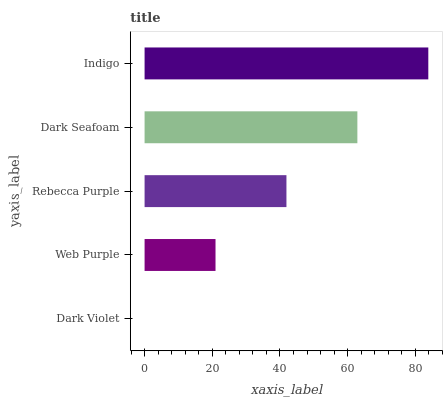Is Dark Violet the minimum?
Answer yes or no. Yes. Is Indigo the maximum?
Answer yes or no. Yes. Is Web Purple the minimum?
Answer yes or no. No. Is Web Purple the maximum?
Answer yes or no. No. Is Web Purple greater than Dark Violet?
Answer yes or no. Yes. Is Dark Violet less than Web Purple?
Answer yes or no. Yes. Is Dark Violet greater than Web Purple?
Answer yes or no. No. Is Web Purple less than Dark Violet?
Answer yes or no. No. Is Rebecca Purple the high median?
Answer yes or no. Yes. Is Rebecca Purple the low median?
Answer yes or no. Yes. Is Dark Seafoam the high median?
Answer yes or no. No. Is Dark Seafoam the low median?
Answer yes or no. No. 